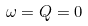<formula> <loc_0><loc_0><loc_500><loc_500>\omega = Q = 0</formula> 